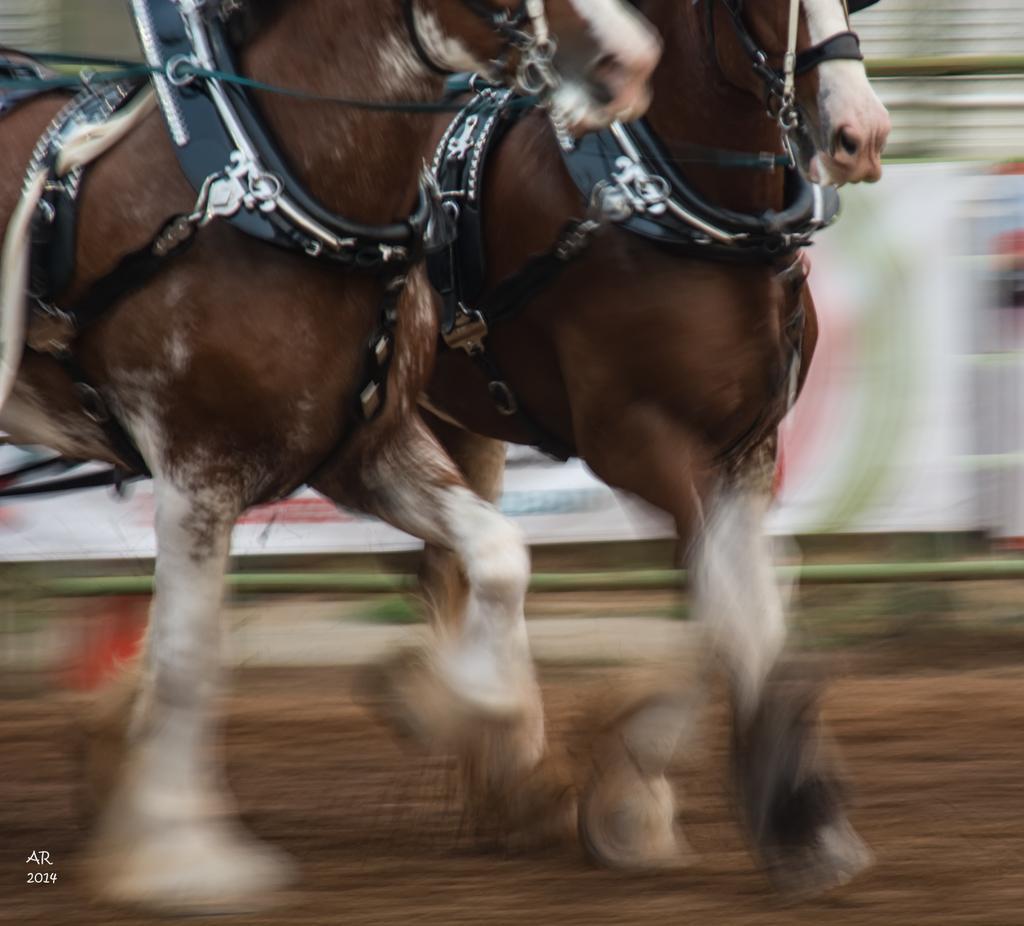Describe this image in one or two sentences. In the foreground of this image, there are two horses running on the ground and the background image is blur. 